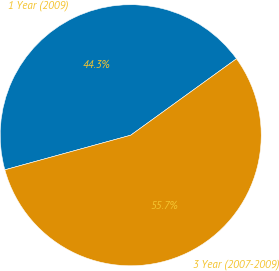Convert chart to OTSL. <chart><loc_0><loc_0><loc_500><loc_500><pie_chart><fcel>1 Year (2009)<fcel>3 Year (2007-2009)<nl><fcel>44.31%<fcel>55.69%<nl></chart> 